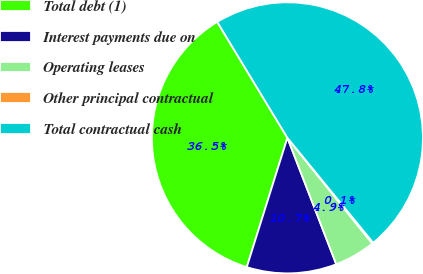Convert chart to OTSL. <chart><loc_0><loc_0><loc_500><loc_500><pie_chart><fcel>Total debt (1)<fcel>Interest payments due on<fcel>Operating leases<fcel>Other principal contractual<fcel>Total contractual cash<nl><fcel>36.49%<fcel>10.71%<fcel>4.9%<fcel>0.14%<fcel>47.76%<nl></chart> 